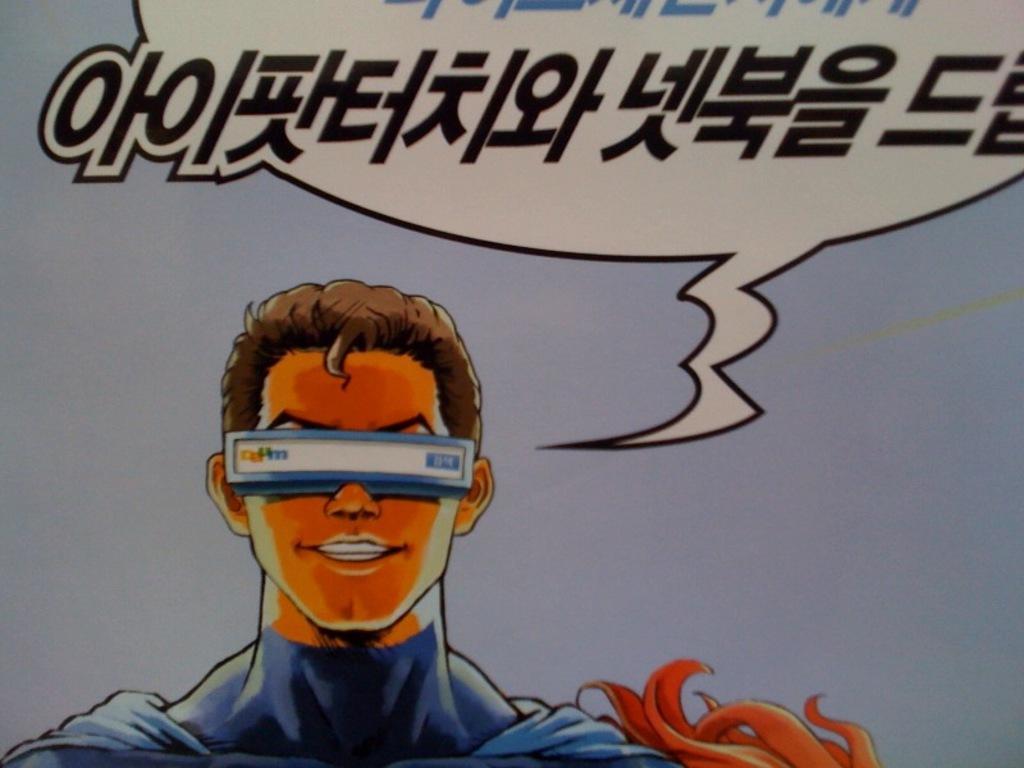Describe this image in one or two sentences. Here we can see a poster, in this poster we can see a person. 